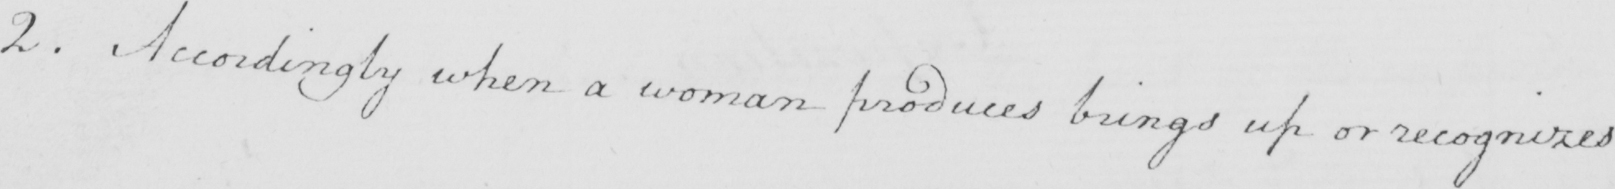What text is written in this handwritten line? 2 . Accordingly when a woman produces brings up or recognizes 